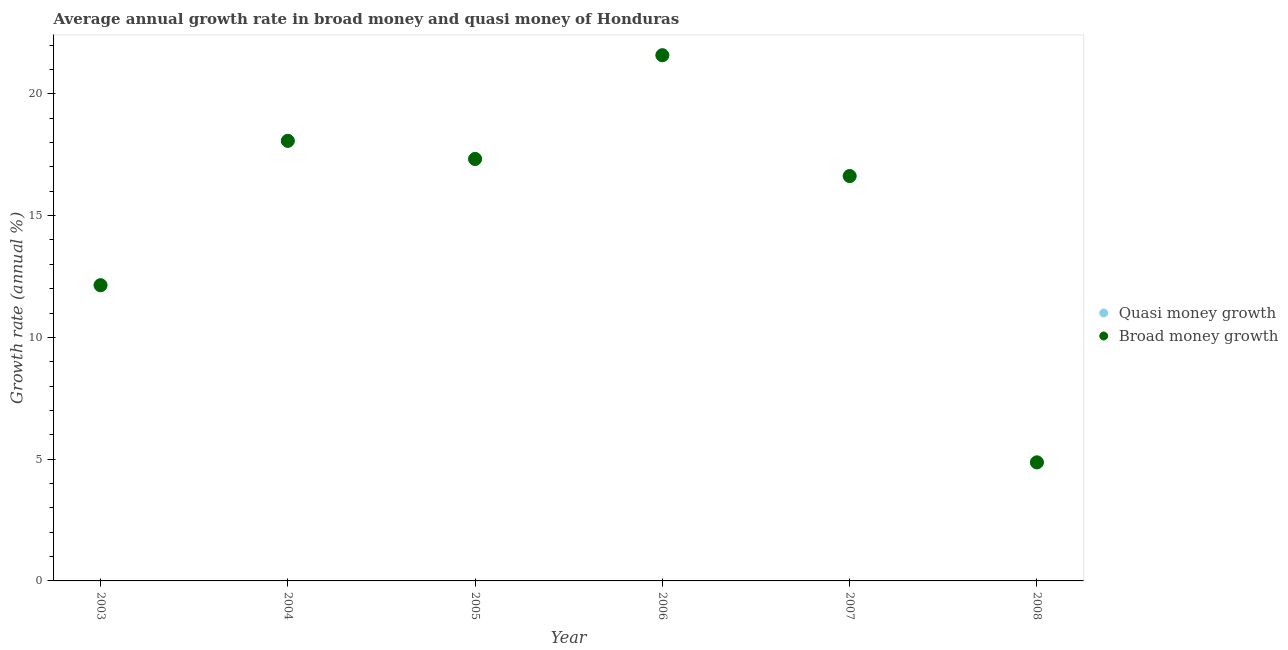Is the number of dotlines equal to the number of legend labels?
Make the answer very short. Yes. What is the annual growth rate in quasi money in 2008?
Give a very brief answer. 4.87. Across all years, what is the maximum annual growth rate in broad money?
Ensure brevity in your answer.  21.59. Across all years, what is the minimum annual growth rate in broad money?
Your answer should be compact. 4.87. In which year was the annual growth rate in broad money minimum?
Your response must be concise. 2008. What is the total annual growth rate in broad money in the graph?
Keep it short and to the point. 90.62. What is the difference between the annual growth rate in broad money in 2006 and that in 2007?
Your response must be concise. 4.96. What is the difference between the annual growth rate in quasi money in 2003 and the annual growth rate in broad money in 2004?
Offer a terse response. -5.93. What is the average annual growth rate in quasi money per year?
Keep it short and to the point. 15.1. In the year 2003, what is the difference between the annual growth rate in broad money and annual growth rate in quasi money?
Offer a very short reply. 0. What is the ratio of the annual growth rate in broad money in 2005 to that in 2006?
Keep it short and to the point. 0.8. What is the difference between the highest and the second highest annual growth rate in quasi money?
Give a very brief answer. 3.51. What is the difference between the highest and the lowest annual growth rate in broad money?
Your answer should be very brief. 16.72. Is the sum of the annual growth rate in broad money in 2003 and 2006 greater than the maximum annual growth rate in quasi money across all years?
Your answer should be very brief. Yes. Does the annual growth rate in quasi money monotonically increase over the years?
Offer a very short reply. No. How many dotlines are there?
Your response must be concise. 2. How many years are there in the graph?
Your answer should be compact. 6. What is the difference between two consecutive major ticks on the Y-axis?
Keep it short and to the point. 5. Are the values on the major ticks of Y-axis written in scientific E-notation?
Provide a short and direct response. No. Does the graph contain any zero values?
Your answer should be very brief. No. How many legend labels are there?
Your answer should be compact. 2. How are the legend labels stacked?
Keep it short and to the point. Vertical. What is the title of the graph?
Your answer should be compact. Average annual growth rate in broad money and quasi money of Honduras. Does "Secondary Education" appear as one of the legend labels in the graph?
Offer a terse response. No. What is the label or title of the Y-axis?
Provide a short and direct response. Growth rate (annual %). What is the Growth rate (annual %) of Quasi money growth in 2003?
Your response must be concise. 12.14. What is the Growth rate (annual %) of Broad money growth in 2003?
Your response must be concise. 12.14. What is the Growth rate (annual %) of Quasi money growth in 2004?
Your answer should be very brief. 18.07. What is the Growth rate (annual %) of Broad money growth in 2004?
Offer a terse response. 18.07. What is the Growth rate (annual %) in Quasi money growth in 2005?
Provide a short and direct response. 17.33. What is the Growth rate (annual %) in Broad money growth in 2005?
Provide a succinct answer. 17.33. What is the Growth rate (annual %) in Quasi money growth in 2006?
Provide a short and direct response. 21.59. What is the Growth rate (annual %) in Broad money growth in 2006?
Give a very brief answer. 21.59. What is the Growth rate (annual %) of Quasi money growth in 2007?
Keep it short and to the point. 16.62. What is the Growth rate (annual %) of Broad money growth in 2007?
Your response must be concise. 16.62. What is the Growth rate (annual %) of Quasi money growth in 2008?
Provide a succinct answer. 4.87. What is the Growth rate (annual %) in Broad money growth in 2008?
Ensure brevity in your answer.  4.87. Across all years, what is the maximum Growth rate (annual %) of Quasi money growth?
Your answer should be very brief. 21.59. Across all years, what is the maximum Growth rate (annual %) of Broad money growth?
Your answer should be very brief. 21.59. Across all years, what is the minimum Growth rate (annual %) of Quasi money growth?
Your answer should be very brief. 4.87. Across all years, what is the minimum Growth rate (annual %) in Broad money growth?
Provide a short and direct response. 4.87. What is the total Growth rate (annual %) of Quasi money growth in the graph?
Offer a very short reply. 90.62. What is the total Growth rate (annual %) in Broad money growth in the graph?
Your answer should be very brief. 90.62. What is the difference between the Growth rate (annual %) in Quasi money growth in 2003 and that in 2004?
Keep it short and to the point. -5.93. What is the difference between the Growth rate (annual %) of Broad money growth in 2003 and that in 2004?
Offer a terse response. -5.93. What is the difference between the Growth rate (annual %) of Quasi money growth in 2003 and that in 2005?
Make the answer very short. -5.18. What is the difference between the Growth rate (annual %) in Broad money growth in 2003 and that in 2005?
Provide a short and direct response. -5.18. What is the difference between the Growth rate (annual %) in Quasi money growth in 2003 and that in 2006?
Ensure brevity in your answer.  -9.44. What is the difference between the Growth rate (annual %) in Broad money growth in 2003 and that in 2006?
Your response must be concise. -9.44. What is the difference between the Growth rate (annual %) in Quasi money growth in 2003 and that in 2007?
Give a very brief answer. -4.48. What is the difference between the Growth rate (annual %) in Broad money growth in 2003 and that in 2007?
Offer a terse response. -4.48. What is the difference between the Growth rate (annual %) in Quasi money growth in 2003 and that in 2008?
Your answer should be very brief. 7.27. What is the difference between the Growth rate (annual %) in Broad money growth in 2003 and that in 2008?
Give a very brief answer. 7.27. What is the difference between the Growth rate (annual %) of Quasi money growth in 2004 and that in 2005?
Your answer should be very brief. 0.74. What is the difference between the Growth rate (annual %) in Broad money growth in 2004 and that in 2005?
Your answer should be very brief. 0.74. What is the difference between the Growth rate (annual %) of Quasi money growth in 2004 and that in 2006?
Your answer should be compact. -3.51. What is the difference between the Growth rate (annual %) of Broad money growth in 2004 and that in 2006?
Provide a succinct answer. -3.51. What is the difference between the Growth rate (annual %) in Quasi money growth in 2004 and that in 2007?
Ensure brevity in your answer.  1.45. What is the difference between the Growth rate (annual %) of Broad money growth in 2004 and that in 2007?
Give a very brief answer. 1.45. What is the difference between the Growth rate (annual %) of Quasi money growth in 2004 and that in 2008?
Your response must be concise. 13.2. What is the difference between the Growth rate (annual %) of Broad money growth in 2004 and that in 2008?
Offer a terse response. 13.2. What is the difference between the Growth rate (annual %) of Quasi money growth in 2005 and that in 2006?
Give a very brief answer. -4.26. What is the difference between the Growth rate (annual %) in Broad money growth in 2005 and that in 2006?
Your answer should be compact. -4.26. What is the difference between the Growth rate (annual %) of Quasi money growth in 2005 and that in 2007?
Give a very brief answer. 0.7. What is the difference between the Growth rate (annual %) of Broad money growth in 2005 and that in 2007?
Keep it short and to the point. 0.7. What is the difference between the Growth rate (annual %) in Quasi money growth in 2005 and that in 2008?
Ensure brevity in your answer.  12.46. What is the difference between the Growth rate (annual %) of Broad money growth in 2005 and that in 2008?
Your answer should be compact. 12.46. What is the difference between the Growth rate (annual %) of Quasi money growth in 2006 and that in 2007?
Your answer should be very brief. 4.96. What is the difference between the Growth rate (annual %) of Broad money growth in 2006 and that in 2007?
Offer a very short reply. 4.96. What is the difference between the Growth rate (annual %) in Quasi money growth in 2006 and that in 2008?
Provide a succinct answer. 16.72. What is the difference between the Growth rate (annual %) in Broad money growth in 2006 and that in 2008?
Your answer should be very brief. 16.72. What is the difference between the Growth rate (annual %) of Quasi money growth in 2007 and that in 2008?
Your response must be concise. 11.76. What is the difference between the Growth rate (annual %) in Broad money growth in 2007 and that in 2008?
Provide a succinct answer. 11.76. What is the difference between the Growth rate (annual %) of Quasi money growth in 2003 and the Growth rate (annual %) of Broad money growth in 2004?
Provide a succinct answer. -5.93. What is the difference between the Growth rate (annual %) of Quasi money growth in 2003 and the Growth rate (annual %) of Broad money growth in 2005?
Ensure brevity in your answer.  -5.18. What is the difference between the Growth rate (annual %) of Quasi money growth in 2003 and the Growth rate (annual %) of Broad money growth in 2006?
Your answer should be very brief. -9.44. What is the difference between the Growth rate (annual %) in Quasi money growth in 2003 and the Growth rate (annual %) in Broad money growth in 2007?
Your response must be concise. -4.48. What is the difference between the Growth rate (annual %) in Quasi money growth in 2003 and the Growth rate (annual %) in Broad money growth in 2008?
Offer a very short reply. 7.27. What is the difference between the Growth rate (annual %) of Quasi money growth in 2004 and the Growth rate (annual %) of Broad money growth in 2005?
Offer a terse response. 0.74. What is the difference between the Growth rate (annual %) in Quasi money growth in 2004 and the Growth rate (annual %) in Broad money growth in 2006?
Your answer should be compact. -3.51. What is the difference between the Growth rate (annual %) in Quasi money growth in 2004 and the Growth rate (annual %) in Broad money growth in 2007?
Make the answer very short. 1.45. What is the difference between the Growth rate (annual %) of Quasi money growth in 2004 and the Growth rate (annual %) of Broad money growth in 2008?
Your answer should be compact. 13.2. What is the difference between the Growth rate (annual %) of Quasi money growth in 2005 and the Growth rate (annual %) of Broad money growth in 2006?
Give a very brief answer. -4.26. What is the difference between the Growth rate (annual %) of Quasi money growth in 2005 and the Growth rate (annual %) of Broad money growth in 2007?
Your answer should be very brief. 0.7. What is the difference between the Growth rate (annual %) in Quasi money growth in 2005 and the Growth rate (annual %) in Broad money growth in 2008?
Provide a short and direct response. 12.46. What is the difference between the Growth rate (annual %) in Quasi money growth in 2006 and the Growth rate (annual %) in Broad money growth in 2007?
Your answer should be compact. 4.96. What is the difference between the Growth rate (annual %) of Quasi money growth in 2006 and the Growth rate (annual %) of Broad money growth in 2008?
Your answer should be very brief. 16.72. What is the difference between the Growth rate (annual %) of Quasi money growth in 2007 and the Growth rate (annual %) of Broad money growth in 2008?
Give a very brief answer. 11.76. What is the average Growth rate (annual %) of Quasi money growth per year?
Your answer should be very brief. 15.1. What is the average Growth rate (annual %) in Broad money growth per year?
Offer a very short reply. 15.1. In the year 2003, what is the difference between the Growth rate (annual %) of Quasi money growth and Growth rate (annual %) of Broad money growth?
Give a very brief answer. 0. In the year 2004, what is the difference between the Growth rate (annual %) of Quasi money growth and Growth rate (annual %) of Broad money growth?
Offer a terse response. 0. In the year 2006, what is the difference between the Growth rate (annual %) of Quasi money growth and Growth rate (annual %) of Broad money growth?
Your answer should be very brief. 0. What is the ratio of the Growth rate (annual %) in Quasi money growth in 2003 to that in 2004?
Ensure brevity in your answer.  0.67. What is the ratio of the Growth rate (annual %) in Broad money growth in 2003 to that in 2004?
Provide a short and direct response. 0.67. What is the ratio of the Growth rate (annual %) of Quasi money growth in 2003 to that in 2005?
Your response must be concise. 0.7. What is the ratio of the Growth rate (annual %) in Broad money growth in 2003 to that in 2005?
Give a very brief answer. 0.7. What is the ratio of the Growth rate (annual %) of Quasi money growth in 2003 to that in 2006?
Your answer should be very brief. 0.56. What is the ratio of the Growth rate (annual %) of Broad money growth in 2003 to that in 2006?
Offer a very short reply. 0.56. What is the ratio of the Growth rate (annual %) of Quasi money growth in 2003 to that in 2007?
Make the answer very short. 0.73. What is the ratio of the Growth rate (annual %) of Broad money growth in 2003 to that in 2007?
Your response must be concise. 0.73. What is the ratio of the Growth rate (annual %) in Quasi money growth in 2003 to that in 2008?
Provide a short and direct response. 2.49. What is the ratio of the Growth rate (annual %) in Broad money growth in 2003 to that in 2008?
Offer a very short reply. 2.49. What is the ratio of the Growth rate (annual %) of Quasi money growth in 2004 to that in 2005?
Provide a succinct answer. 1.04. What is the ratio of the Growth rate (annual %) in Broad money growth in 2004 to that in 2005?
Give a very brief answer. 1.04. What is the ratio of the Growth rate (annual %) of Quasi money growth in 2004 to that in 2006?
Provide a short and direct response. 0.84. What is the ratio of the Growth rate (annual %) in Broad money growth in 2004 to that in 2006?
Ensure brevity in your answer.  0.84. What is the ratio of the Growth rate (annual %) of Quasi money growth in 2004 to that in 2007?
Your answer should be compact. 1.09. What is the ratio of the Growth rate (annual %) of Broad money growth in 2004 to that in 2007?
Provide a short and direct response. 1.09. What is the ratio of the Growth rate (annual %) of Quasi money growth in 2004 to that in 2008?
Ensure brevity in your answer.  3.71. What is the ratio of the Growth rate (annual %) in Broad money growth in 2004 to that in 2008?
Provide a succinct answer. 3.71. What is the ratio of the Growth rate (annual %) in Quasi money growth in 2005 to that in 2006?
Provide a succinct answer. 0.8. What is the ratio of the Growth rate (annual %) of Broad money growth in 2005 to that in 2006?
Provide a short and direct response. 0.8. What is the ratio of the Growth rate (annual %) of Quasi money growth in 2005 to that in 2007?
Provide a succinct answer. 1.04. What is the ratio of the Growth rate (annual %) in Broad money growth in 2005 to that in 2007?
Offer a very short reply. 1.04. What is the ratio of the Growth rate (annual %) of Quasi money growth in 2005 to that in 2008?
Offer a very short reply. 3.56. What is the ratio of the Growth rate (annual %) of Broad money growth in 2005 to that in 2008?
Provide a short and direct response. 3.56. What is the ratio of the Growth rate (annual %) of Quasi money growth in 2006 to that in 2007?
Keep it short and to the point. 1.3. What is the ratio of the Growth rate (annual %) in Broad money growth in 2006 to that in 2007?
Your answer should be compact. 1.3. What is the ratio of the Growth rate (annual %) in Quasi money growth in 2006 to that in 2008?
Make the answer very short. 4.43. What is the ratio of the Growth rate (annual %) in Broad money growth in 2006 to that in 2008?
Provide a short and direct response. 4.43. What is the ratio of the Growth rate (annual %) of Quasi money growth in 2007 to that in 2008?
Keep it short and to the point. 3.41. What is the ratio of the Growth rate (annual %) of Broad money growth in 2007 to that in 2008?
Offer a very short reply. 3.41. What is the difference between the highest and the second highest Growth rate (annual %) in Quasi money growth?
Offer a very short reply. 3.51. What is the difference between the highest and the second highest Growth rate (annual %) of Broad money growth?
Ensure brevity in your answer.  3.51. What is the difference between the highest and the lowest Growth rate (annual %) in Quasi money growth?
Make the answer very short. 16.72. What is the difference between the highest and the lowest Growth rate (annual %) of Broad money growth?
Your answer should be very brief. 16.72. 